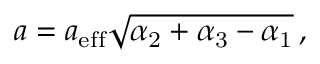<formula> <loc_0><loc_0><loc_500><loc_500>a = a _ { e f f } \sqrt { \alpha _ { 2 } + \alpha _ { 3 } - \alpha _ { 1 } } \, ,</formula> 